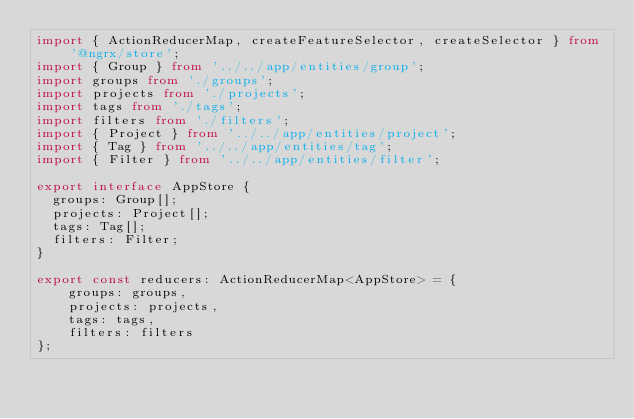<code> <loc_0><loc_0><loc_500><loc_500><_TypeScript_>import { ActionReducerMap, createFeatureSelector, createSelector } from '@ngrx/store';
import { Group } from '../../app/entities/group';
import groups from './groups';
import projects from './projects';
import tags from './tags';
import filters from './filters';
import { Project } from '../../app/entities/project';
import { Tag } from '../../app/entities/tag';
import { Filter } from '../../app/entities/filter';

export interface AppStore {
  groups: Group[];
  projects: Project[];
  tags: Tag[];
  filters: Filter;
}

export const reducers: ActionReducerMap<AppStore> = {
    groups: groups,
    projects: projects,
    tags: tags,
    filters: filters
};</code> 